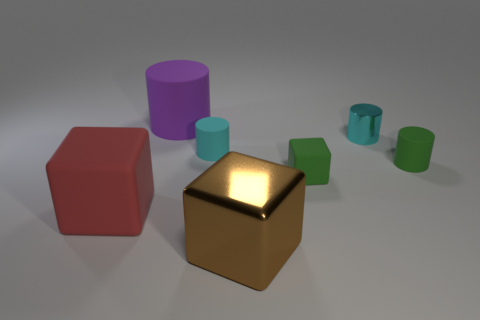Subtract all large matte blocks. How many blocks are left? 2 Add 3 big green metal balls. How many objects exist? 10 Subtract all red cubes. How many cubes are left? 2 Subtract all cubes. How many objects are left? 4 Subtract all tiny purple shiny objects. Subtract all tiny blocks. How many objects are left? 6 Add 5 small cyan matte cylinders. How many small cyan matte cylinders are left? 6 Add 4 green matte objects. How many green matte objects exist? 6 Subtract 0 brown spheres. How many objects are left? 7 Subtract 3 cubes. How many cubes are left? 0 Subtract all red blocks. Subtract all yellow cylinders. How many blocks are left? 2 